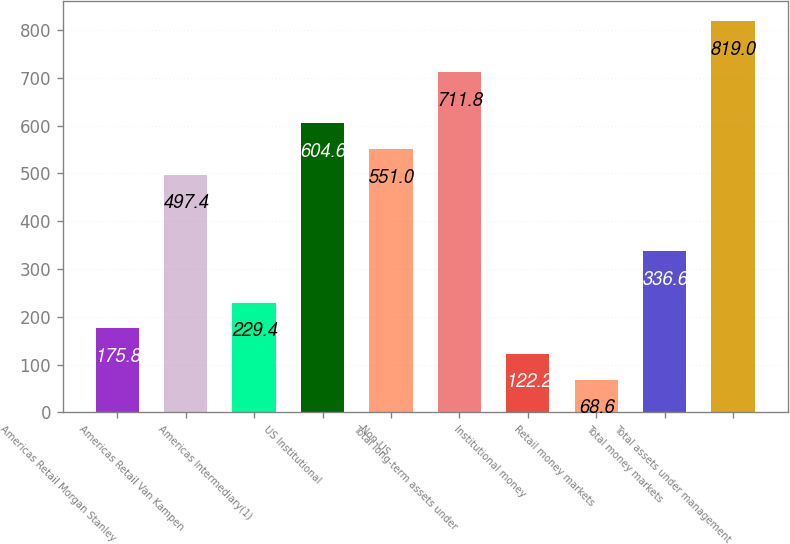Convert chart to OTSL. <chart><loc_0><loc_0><loc_500><loc_500><bar_chart><fcel>Americas Retail Morgan Stanley<fcel>Americas Retail Van Kampen<fcel>Americas Intermediary(1)<fcel>US Institutional<fcel>Non-US<fcel>Total long-term assets under<fcel>Institutional money<fcel>Retail money markets<fcel>Total money markets<fcel>Total assets under management<nl><fcel>175.8<fcel>497.4<fcel>229.4<fcel>604.6<fcel>551<fcel>711.8<fcel>122.2<fcel>68.6<fcel>336.6<fcel>819<nl></chart> 